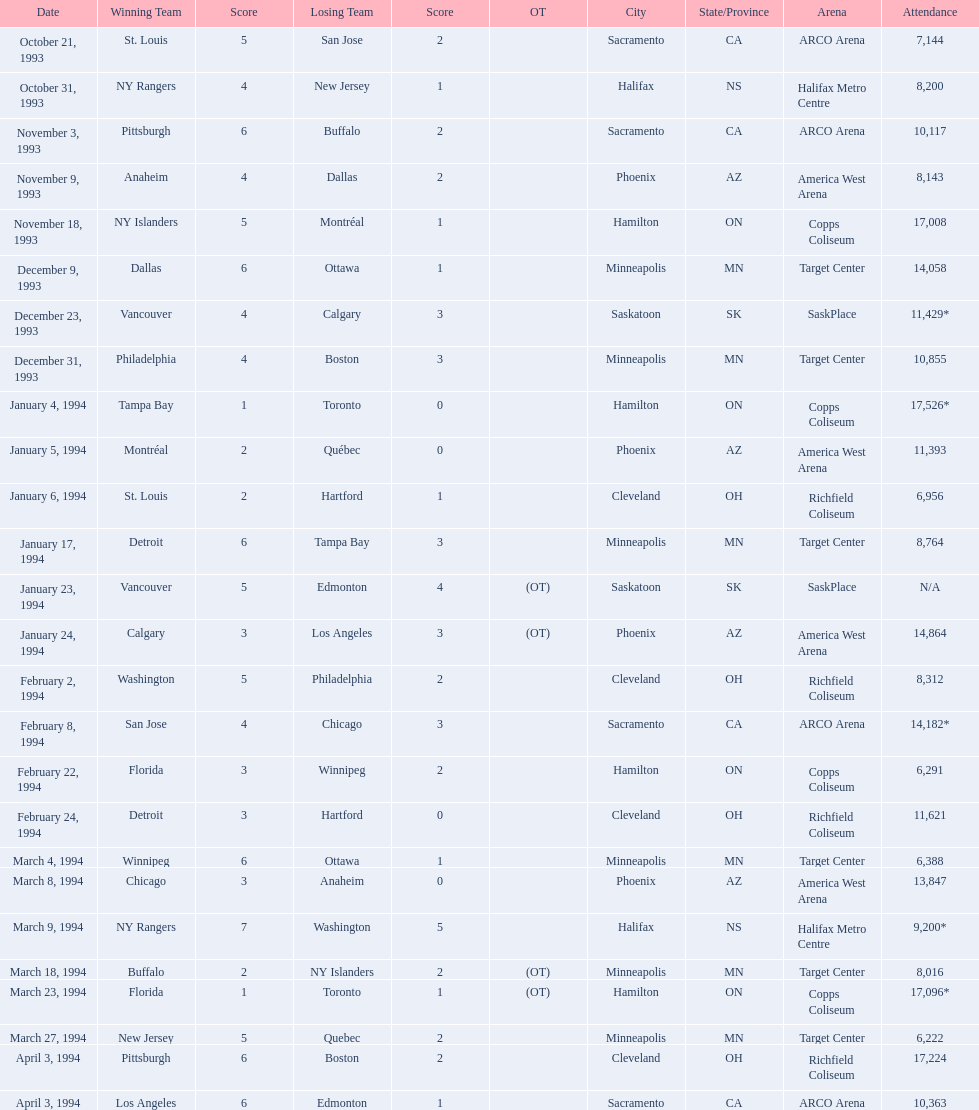Which days observed the triumphant team earning merely one point? January 4, 1994, March 23, 1994. Between these two, which day had higher crowd presence? January 4, 1994. 